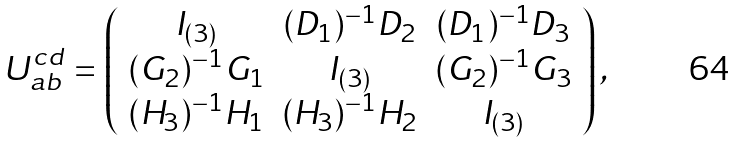Convert formula to latex. <formula><loc_0><loc_0><loc_500><loc_500>U _ { a b } ^ { c d } = \left ( \begin{array} { c c c } I _ { ( 3 ) } & ( D _ { 1 } ) ^ { - 1 } D _ { 2 } & ( D _ { 1 } ) ^ { - 1 } D _ { 3 } \\ ( G _ { 2 } ) ^ { - 1 } G _ { 1 } & I _ { ( 3 ) } & ( G _ { 2 } ) ^ { - 1 } G _ { 3 } \\ ( H _ { 3 } ) ^ { - 1 } H _ { 1 } & ( H _ { 3 } ) ^ { - 1 } H _ { 2 } & I _ { ( 3 ) } \\ \end{array} \right ) ,</formula> 